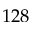<formula> <loc_0><loc_0><loc_500><loc_500>1 2 8</formula> 